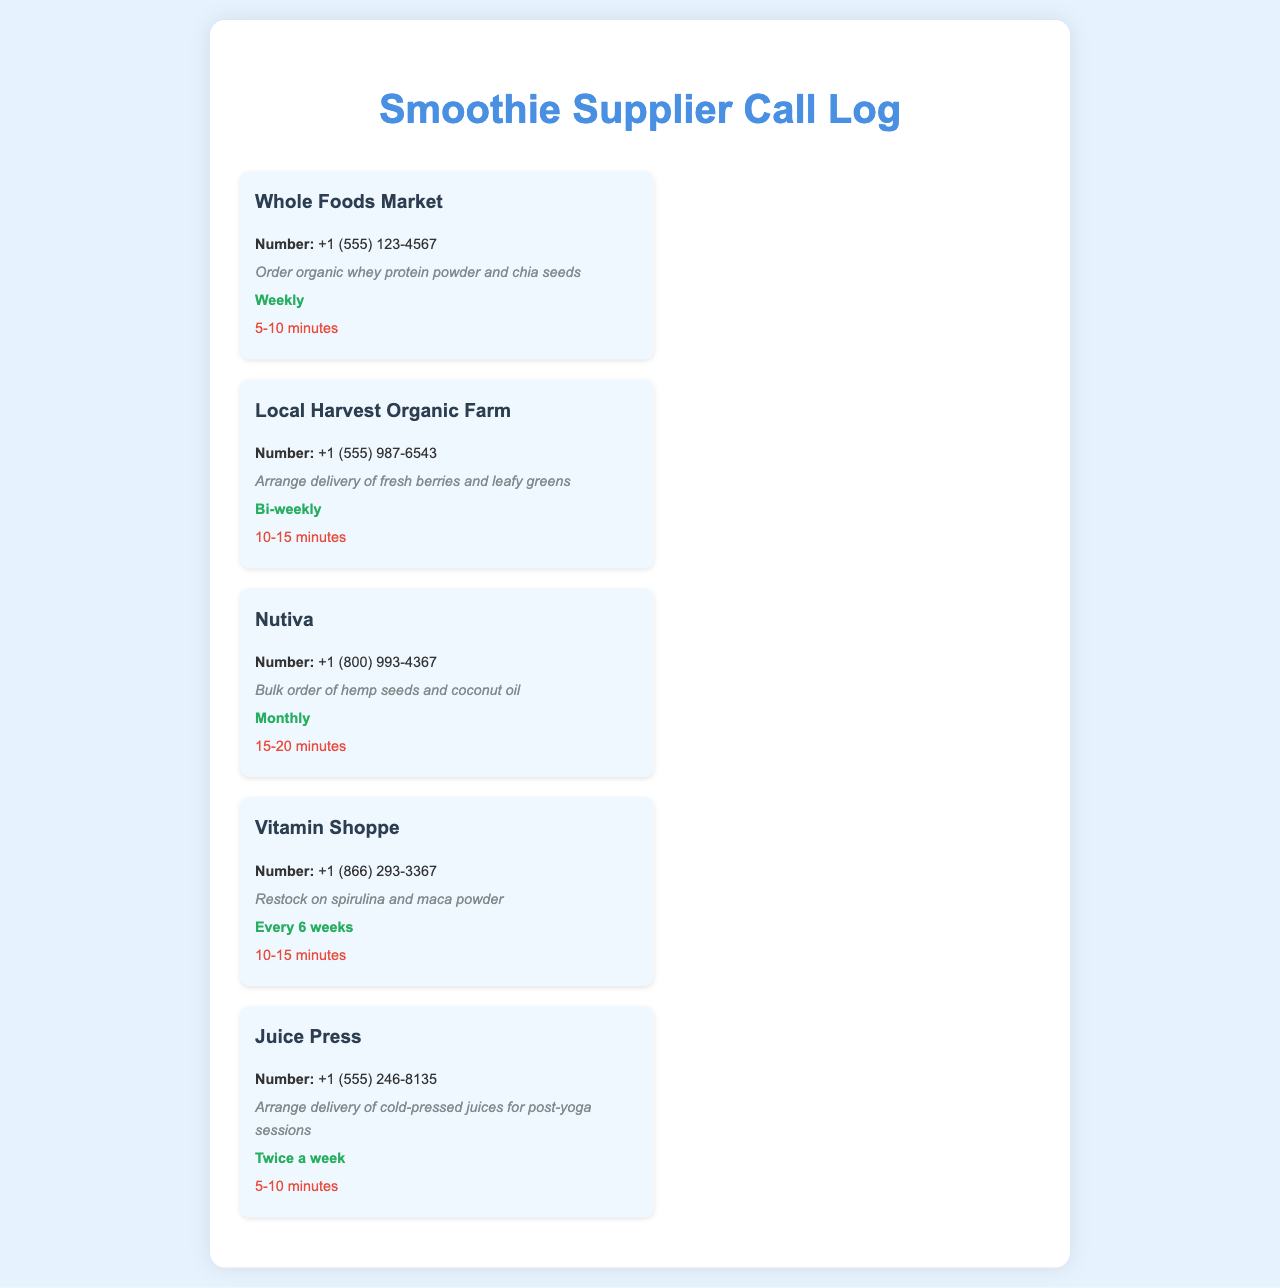what is the phone number for Whole Foods Market? The phone number for Whole Foods Market is listed in the document as +1 (555) 123-4567.
Answer: +1 (555) 123-4567 how often do you call Local Harvest Organic Farm? The frequency of calls to Local Harvest Organic Farm is stated as bi-weekly in the document.
Answer: Bi-weekly what is the purpose of the call to Nutiva? The purpose of the call to Nutiva is described as a bulk order of hemp seeds and coconut oil.
Answer: Bulk order of hemp seeds and coconut oil how long does the call to Juice Press typically last? The duration for the call to Juice Press is stated in the document as 5-10 minutes.
Answer: 5-10 minutes which supplier is contacted every 6 weeks? The document specifies that calls to Vitamin Shoppe are made every 6 weeks.
Answer: Vitamin Shoppe how many suppliers are listed in total? The document contains a total of five suppliers listed in the call log section.
Answer: Five which supplier does the athlete arrange delivery of cold-pressed juices from? The athlete arranges delivery of cold-pressed juices from Juice Press according to the document.
Answer: Juice Press what is the first ingredient ordered from Whole Foods Market? The first ingredient ordered from Whole Foods Market is organic whey protein powder, as indicated in the call log.
Answer: Organic whey protein powder 